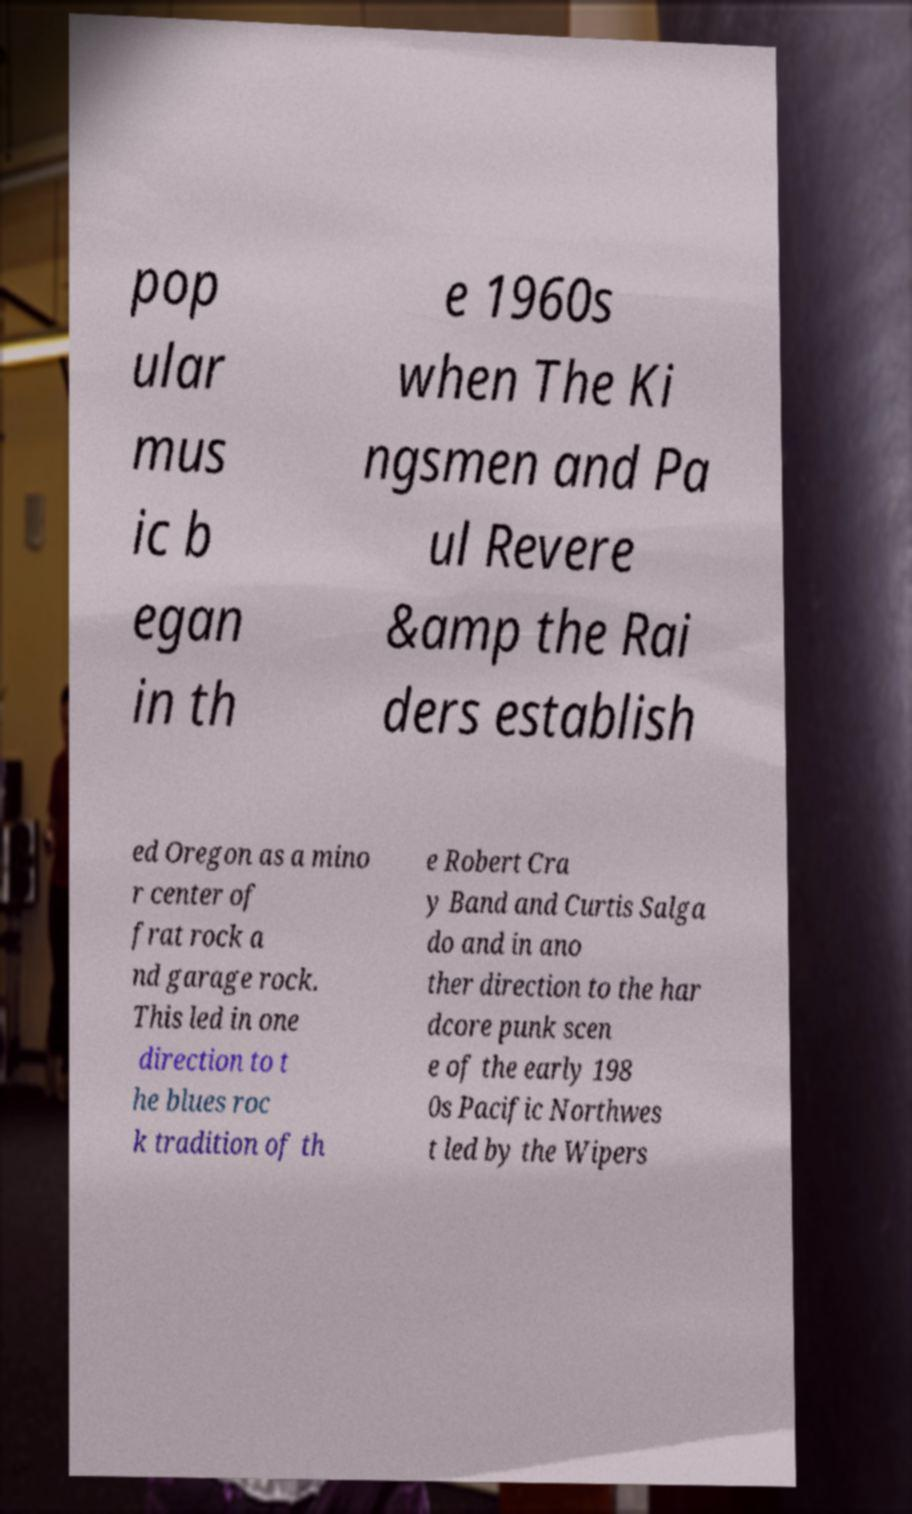Could you extract and type out the text from this image? pop ular mus ic b egan in th e 1960s when The Ki ngsmen and Pa ul Revere &amp the Rai ders establish ed Oregon as a mino r center of frat rock a nd garage rock. This led in one direction to t he blues roc k tradition of th e Robert Cra y Band and Curtis Salga do and in ano ther direction to the har dcore punk scen e of the early 198 0s Pacific Northwes t led by the Wipers 